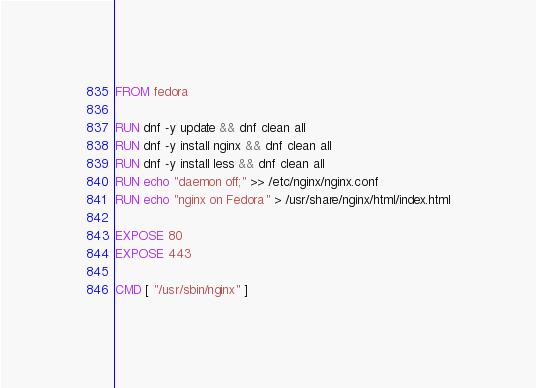Convert code to text. <code><loc_0><loc_0><loc_500><loc_500><_Dockerfile_>FROM fedora

RUN dnf -y update && dnf clean all
RUN dnf -y install nginx && dnf clean all
RUN dnf -y install less && dnf clean all
RUN echo "daemon off;" >> /etc/nginx/nginx.conf
RUN echo "nginx on Fedora" > /usr/share/nginx/html/index.html

EXPOSE 80
EXPOSE 443

CMD [ "/usr/sbin/nginx" ]</code> 